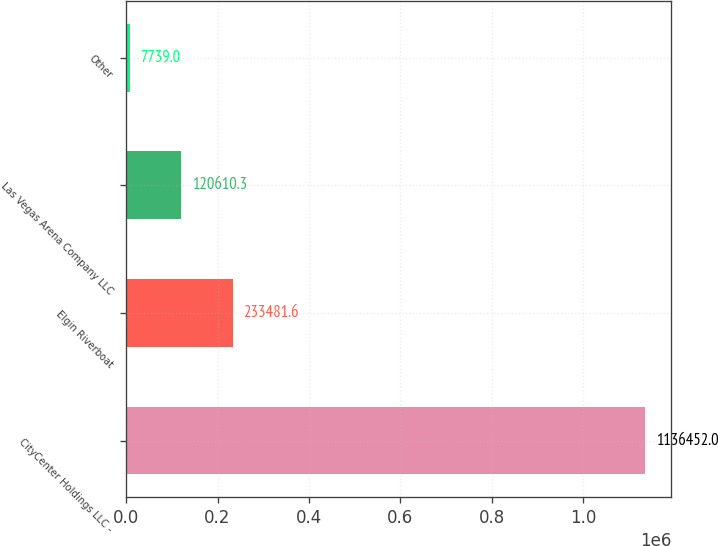Convert chart to OTSL. <chart><loc_0><loc_0><loc_500><loc_500><bar_chart><fcel>CityCenter Holdings LLC -<fcel>Elgin Riverboat<fcel>Las Vegas Arena Company LLC<fcel>Other<nl><fcel>1.13645e+06<fcel>233482<fcel>120610<fcel>7739<nl></chart> 